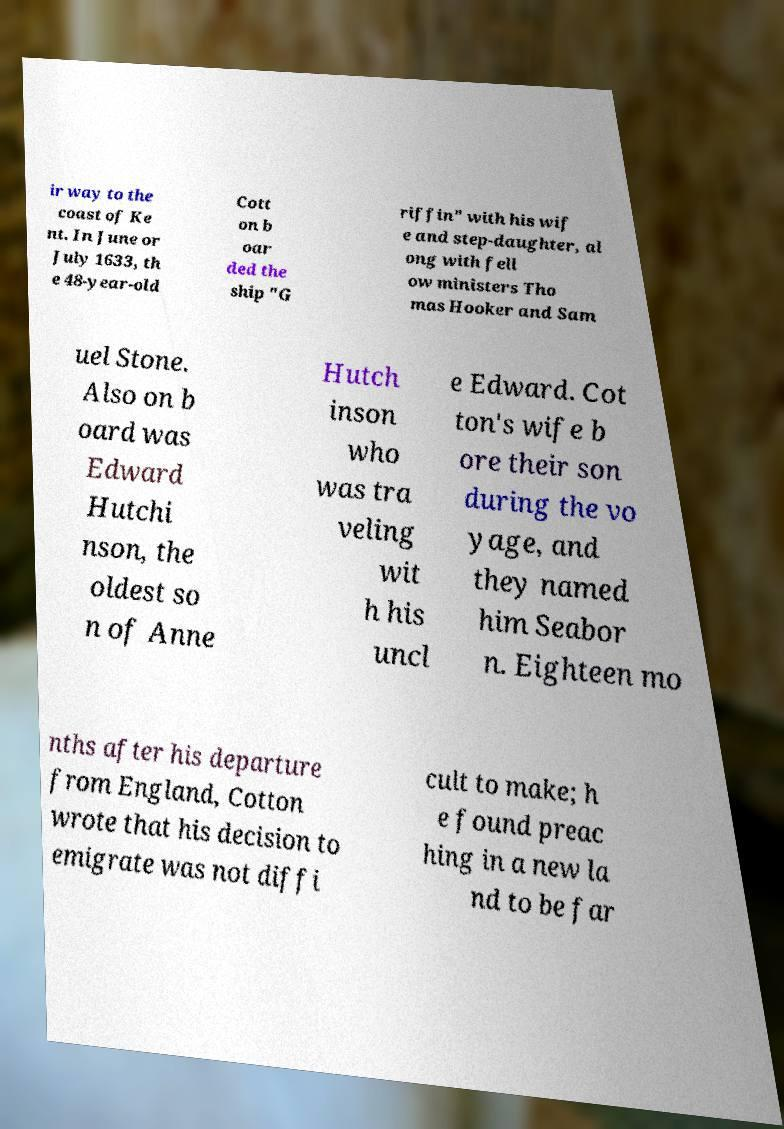Could you extract and type out the text from this image? ir way to the coast of Ke nt. In June or July 1633, th e 48-year-old Cott on b oar ded the ship "G riffin" with his wif e and step-daughter, al ong with fell ow ministers Tho mas Hooker and Sam uel Stone. Also on b oard was Edward Hutchi nson, the oldest so n of Anne Hutch inson who was tra veling wit h his uncl e Edward. Cot ton's wife b ore their son during the vo yage, and they named him Seabor n. Eighteen mo nths after his departure from England, Cotton wrote that his decision to emigrate was not diffi cult to make; h e found preac hing in a new la nd to be far 